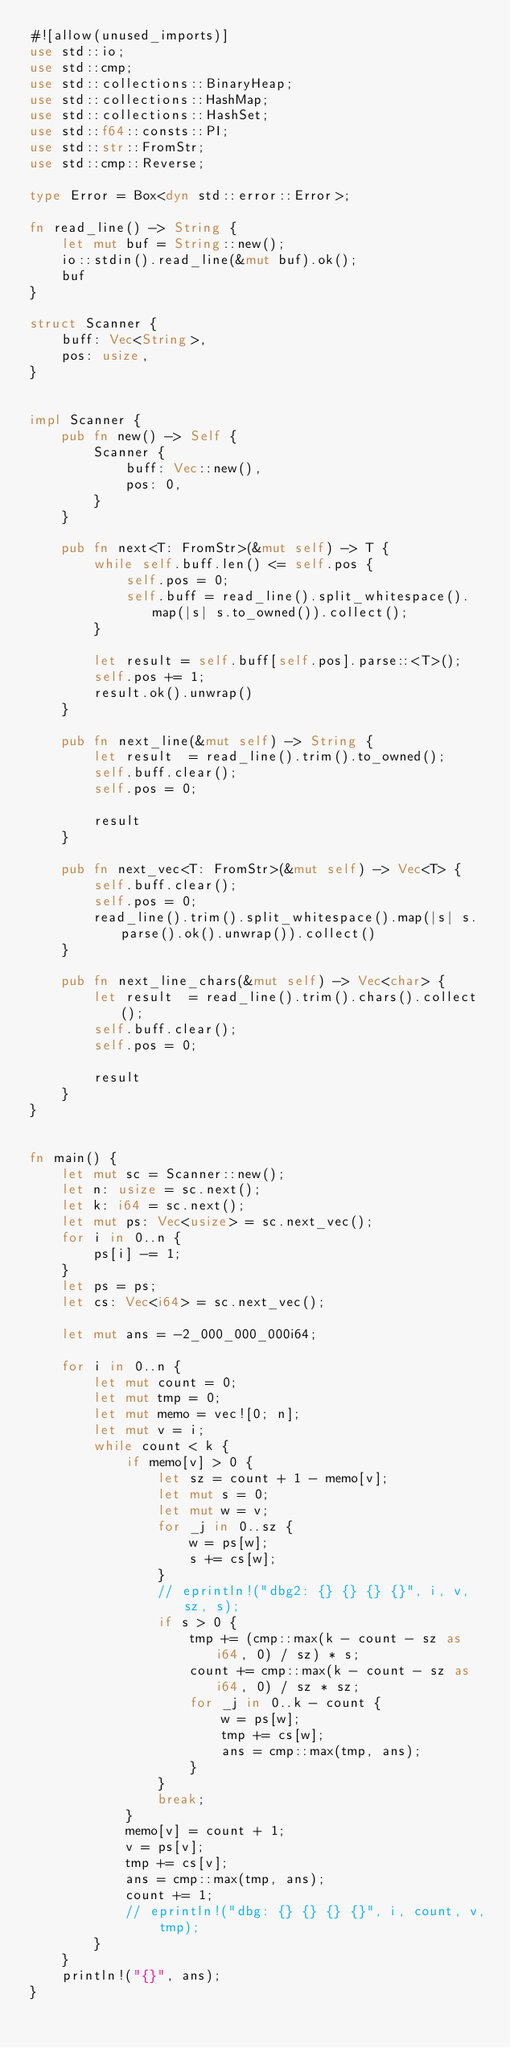<code> <loc_0><loc_0><loc_500><loc_500><_Rust_>#![allow(unused_imports)]
use std::io;
use std::cmp;
use std::collections::BinaryHeap;
use std::collections::HashMap;
use std::collections::HashSet;
use std::f64::consts::PI;
use std::str::FromStr;
use std::cmp::Reverse;

type Error = Box<dyn std::error::Error>;

fn read_line() -> String {
    let mut buf = String::new();
    io::stdin().read_line(&mut buf).ok();
    buf
}

struct Scanner {
    buff: Vec<String>,
    pos: usize,
}


impl Scanner {
    pub fn new() -> Self {
        Scanner {
            buff: Vec::new(),
            pos: 0,
        }
    }

    pub fn next<T: FromStr>(&mut self) -> T {
        while self.buff.len() <= self.pos {
            self.pos = 0;
            self.buff = read_line().split_whitespace().map(|s| s.to_owned()).collect();
        }

        let result = self.buff[self.pos].parse::<T>();
        self.pos += 1;
        result.ok().unwrap()
    }

    pub fn next_line(&mut self) -> String {
        let result  = read_line().trim().to_owned();
        self.buff.clear();
        self.pos = 0;

        result
    }

    pub fn next_vec<T: FromStr>(&mut self) -> Vec<T> {
        self.buff.clear();
        self.pos = 0;
        read_line().trim().split_whitespace().map(|s| s.parse().ok().unwrap()).collect()
    }
    
    pub fn next_line_chars(&mut self) -> Vec<char> {
        let result  = read_line().trim().chars().collect();
        self.buff.clear();
        self.pos = 0;

        result
    }
}


fn main() {
    let mut sc = Scanner::new();
    let n: usize = sc.next();
    let k: i64 = sc.next();
    let mut ps: Vec<usize> = sc.next_vec();
    for i in 0..n {
        ps[i] -= 1;
    }
    let ps = ps;
    let cs: Vec<i64> = sc.next_vec();

    let mut ans = -2_000_000_000i64;

    for i in 0..n {
        let mut count = 0;
        let mut tmp = 0;
        let mut memo = vec![0; n];
        let mut v = i;
        while count < k {
            if memo[v] > 0 {
                let sz = count + 1 - memo[v];
                let mut s = 0;
                let mut w = v;
                for _j in 0..sz {
                    w = ps[w];
                    s += cs[w];
                }
                // eprintln!("dbg2: {} {} {} {}", i, v, sz, s);
                if s > 0 {
                    tmp += (cmp::max(k - count - sz as i64, 0) / sz) * s;
                    count += cmp::max(k - count - sz as i64, 0) / sz * sz;
                    for _j in 0..k - count {
                        w = ps[w];
                        tmp += cs[w];
                        ans = cmp::max(tmp, ans);
                    }
                }
                break;
            }
            memo[v] = count + 1;
            v = ps[v];
            tmp += cs[v];
            ans = cmp::max(tmp, ans);
            count += 1;
            // eprintln!("dbg: {} {} {} {}", i, count, v, tmp);
        }
    }
    println!("{}", ans);
}
</code> 